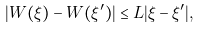<formula> <loc_0><loc_0><loc_500><loc_500>| W ( \xi ) - W ( \xi ^ { \prime } ) | \leq L | \xi - \xi ^ { \prime } | ,</formula> 